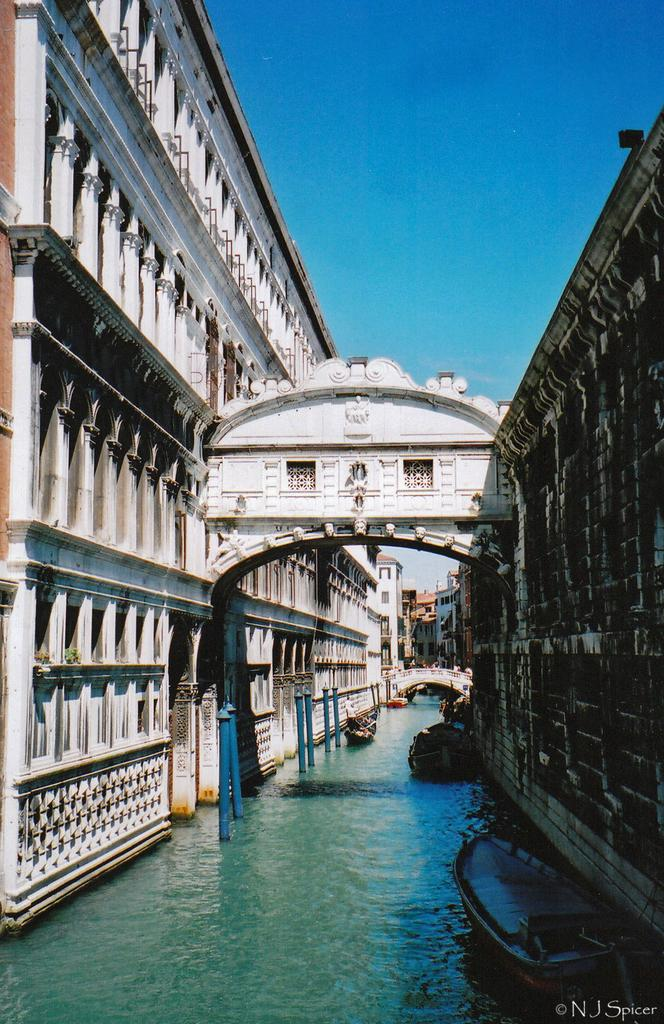What color is the sky in the image? The sky is blue in the image. What type of structures can be seen in the image? There are buildings visible in the image. Where are the boats located in the image? The boats are above the water in the image. What type of pin can be seen holding up a poster in the image? There is no pin or poster present in the image. Where is the lunchroom located in the image? There is no lunchroom present in the image. 